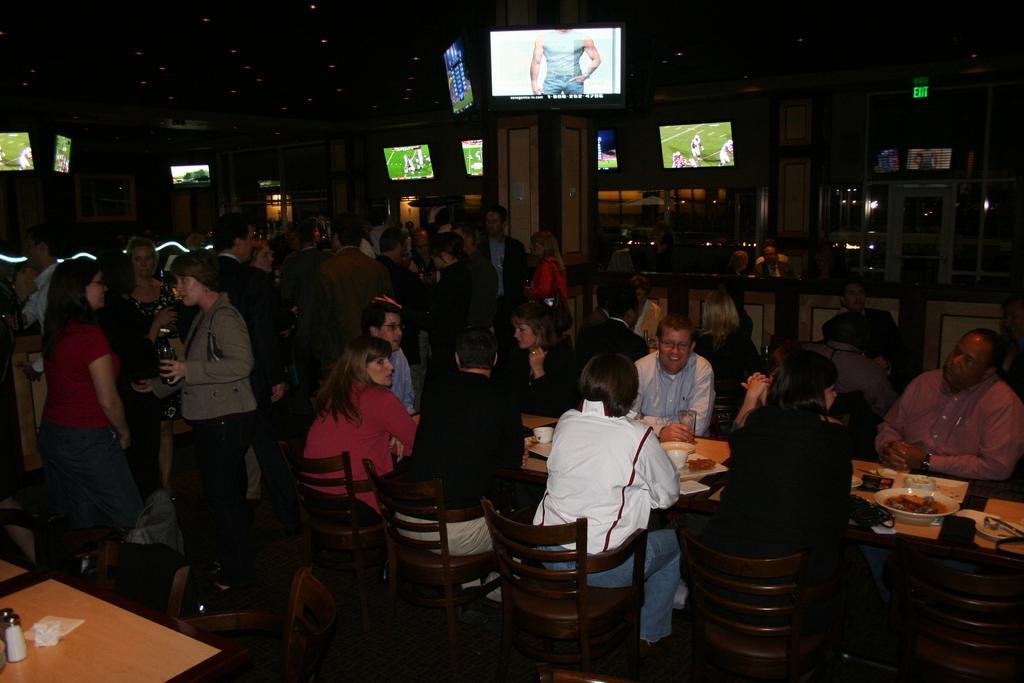Please provide a concise description of this image. In this image I can see people were few of them are sitting on chairs and rest all are standing. I can also see tables and number of screens in the background. 